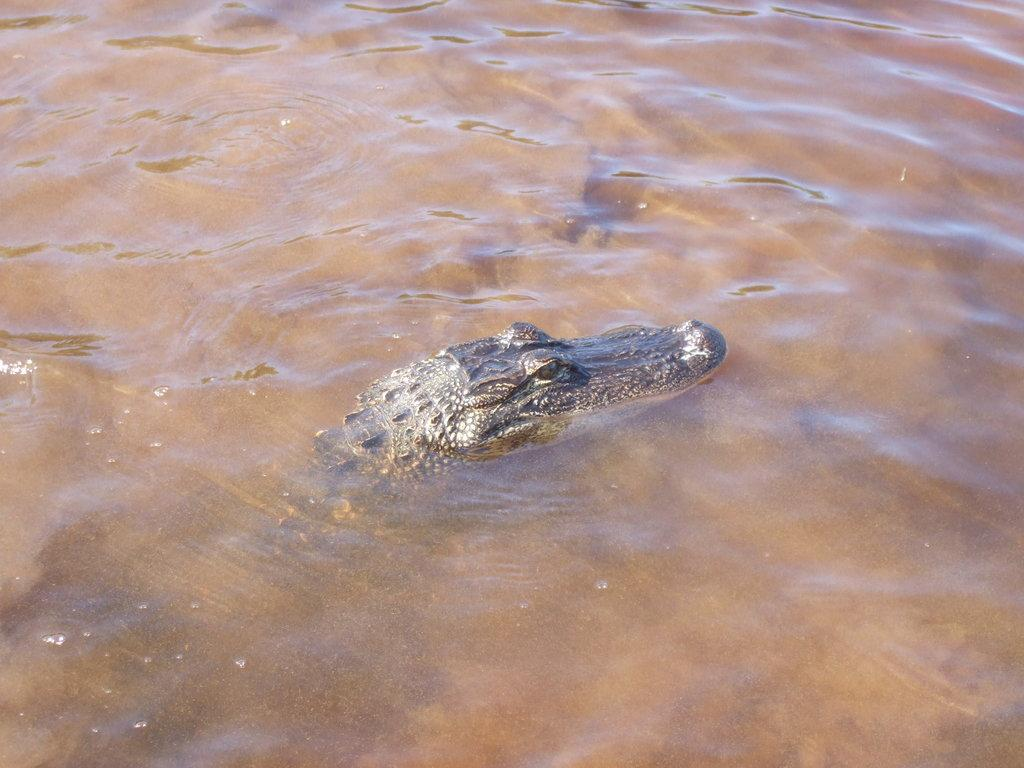What type of animal can be seen in the water in the image? There is a crocodile in the water in the image. What type of instrument is the crocodile playing in the image? There is no instrument present in the image, and the crocodile is not playing any instrument. How many times does the crocodile kick its legs in the image? The image does not show the crocodile kicking its legs, so it cannot be determined how many times it does so. 